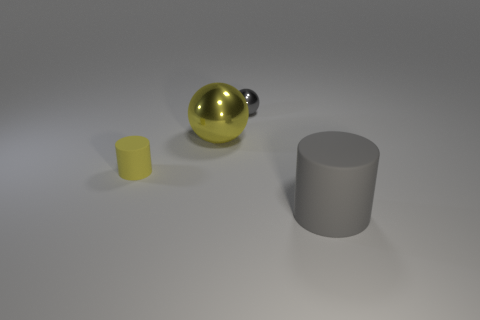Subtract all cyan balls. Subtract all yellow cylinders. How many balls are left? 2 Add 3 shiny balls. How many objects exist? 7 Subtract 0 cyan cylinders. How many objects are left? 4 Subtract all tiny brown matte objects. Subtract all gray things. How many objects are left? 2 Add 1 metallic balls. How many metallic balls are left? 3 Add 1 large red shiny cubes. How many large red shiny cubes exist? 1 